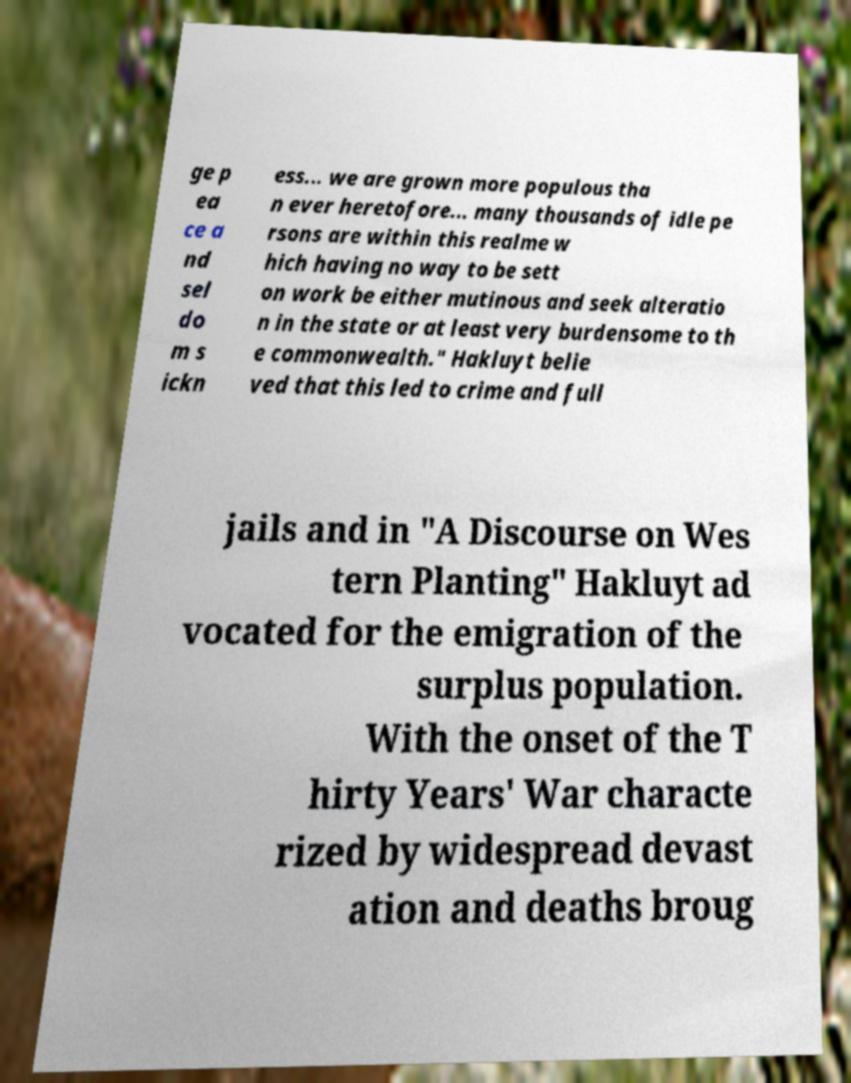I need the written content from this picture converted into text. Can you do that? ge p ea ce a nd sel do m s ickn ess... we are grown more populous tha n ever heretofore... many thousands of idle pe rsons are within this realme w hich having no way to be sett on work be either mutinous and seek alteratio n in the state or at least very burdensome to th e commonwealth." Hakluyt belie ved that this led to crime and full jails and in "A Discourse on Wes tern Planting" Hakluyt ad vocated for the emigration of the surplus population. With the onset of the T hirty Years' War characte rized by widespread devast ation and deaths broug 